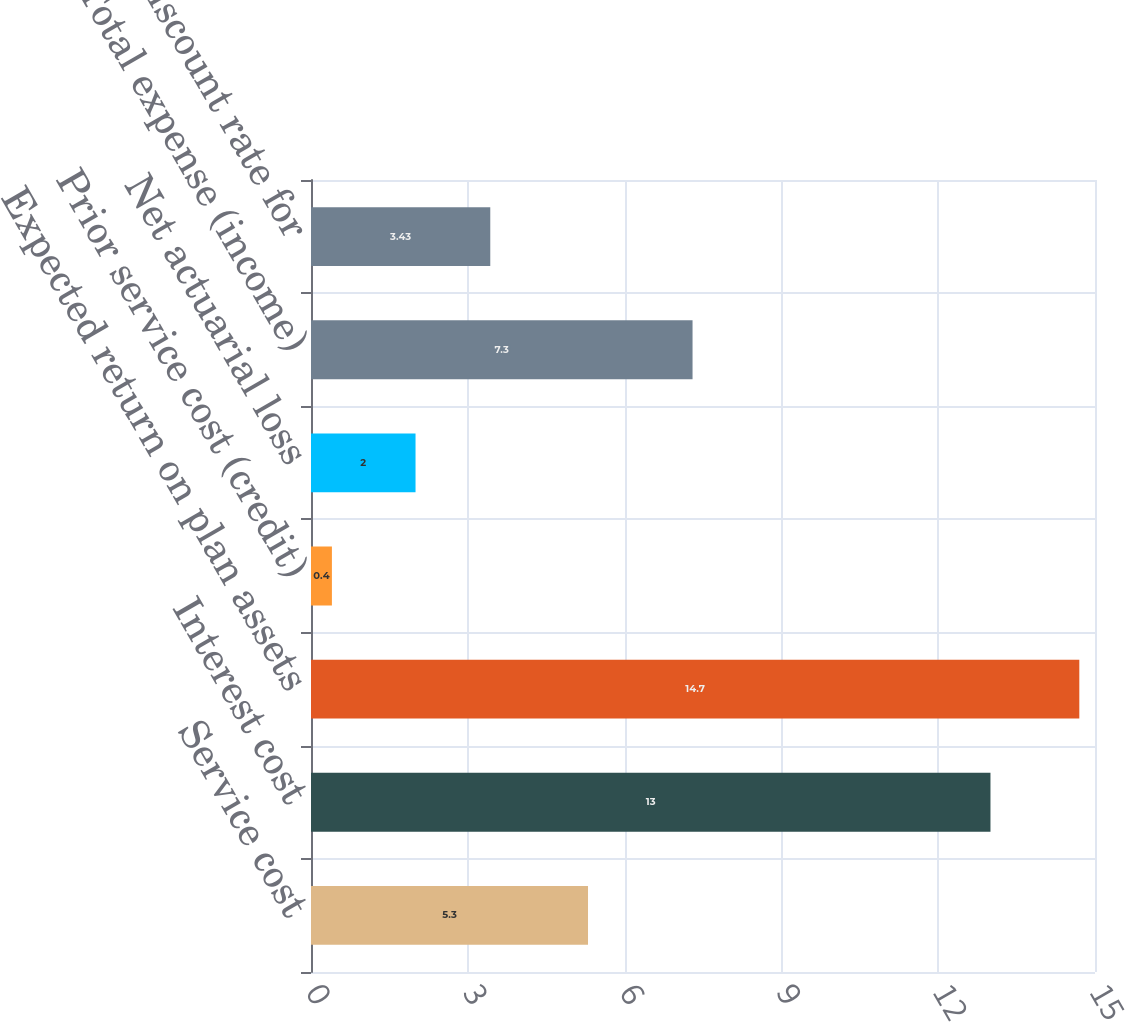<chart> <loc_0><loc_0><loc_500><loc_500><bar_chart><fcel>Service cost<fcel>Interest cost<fcel>Expected return on plan assets<fcel>Prior service cost (credit)<fcel>Net actuarial loss<fcel>Total expense (income)<fcel>Effective discount rate for<nl><fcel>5.3<fcel>13<fcel>14.7<fcel>0.4<fcel>2<fcel>7.3<fcel>3.43<nl></chart> 